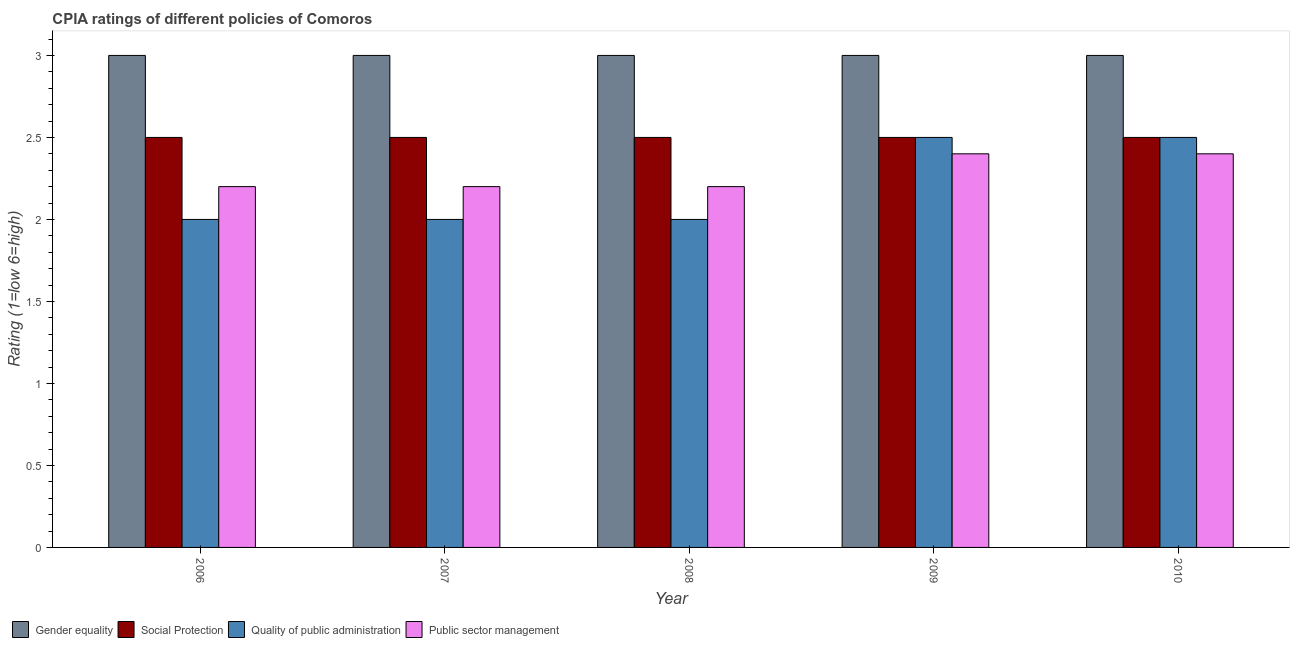How many groups of bars are there?
Offer a very short reply. 5. Are the number of bars on each tick of the X-axis equal?
Keep it short and to the point. Yes. What is the cpia rating of gender equality in 2008?
Your answer should be very brief. 3. Across all years, what is the minimum cpia rating of public sector management?
Make the answer very short. 2.2. What is the total cpia rating of social protection in the graph?
Offer a very short reply. 12.5. What is the difference between the cpia rating of public sector management in 2006 and that in 2010?
Your answer should be compact. -0.2. What is the difference between the cpia rating of gender equality in 2008 and the cpia rating of quality of public administration in 2010?
Make the answer very short. 0. What is the average cpia rating of public sector management per year?
Provide a short and direct response. 2.28. In how many years, is the cpia rating of quality of public administration greater than 2.6?
Provide a succinct answer. 0. What is the ratio of the cpia rating of social protection in 2007 to that in 2009?
Your response must be concise. 1. What is the difference between the highest and the second highest cpia rating of gender equality?
Your response must be concise. 0. In how many years, is the cpia rating of quality of public administration greater than the average cpia rating of quality of public administration taken over all years?
Your response must be concise. 2. Is the sum of the cpia rating of social protection in 2007 and 2009 greater than the maximum cpia rating of quality of public administration across all years?
Make the answer very short. Yes. What does the 2nd bar from the left in 2009 represents?
Give a very brief answer. Social Protection. What does the 3rd bar from the right in 2010 represents?
Provide a succinct answer. Social Protection. How many bars are there?
Offer a terse response. 20. Does the graph contain any zero values?
Your answer should be very brief. No. Where does the legend appear in the graph?
Your answer should be compact. Bottom left. How are the legend labels stacked?
Offer a terse response. Horizontal. What is the title of the graph?
Offer a terse response. CPIA ratings of different policies of Comoros. What is the Rating (1=low 6=high) in Public sector management in 2006?
Your response must be concise. 2.2. What is the Rating (1=low 6=high) of Gender equality in 2007?
Ensure brevity in your answer.  3. What is the Rating (1=low 6=high) in Public sector management in 2008?
Offer a terse response. 2.2. What is the Rating (1=low 6=high) of Quality of public administration in 2009?
Give a very brief answer. 2.5. What is the Rating (1=low 6=high) of Gender equality in 2010?
Provide a succinct answer. 3. What is the Rating (1=low 6=high) in Public sector management in 2010?
Your response must be concise. 2.4. Across all years, what is the maximum Rating (1=low 6=high) of Gender equality?
Your response must be concise. 3. Across all years, what is the maximum Rating (1=low 6=high) of Social Protection?
Provide a succinct answer. 2.5. Across all years, what is the maximum Rating (1=low 6=high) of Public sector management?
Offer a very short reply. 2.4. Across all years, what is the minimum Rating (1=low 6=high) in Gender equality?
Provide a succinct answer. 3. Across all years, what is the minimum Rating (1=low 6=high) of Social Protection?
Offer a very short reply. 2.5. Across all years, what is the minimum Rating (1=low 6=high) of Public sector management?
Keep it short and to the point. 2.2. What is the total Rating (1=low 6=high) in Quality of public administration in the graph?
Your answer should be compact. 11. What is the difference between the Rating (1=low 6=high) of Social Protection in 2006 and that in 2007?
Ensure brevity in your answer.  0. What is the difference between the Rating (1=low 6=high) in Quality of public administration in 2006 and that in 2007?
Your response must be concise. 0. What is the difference between the Rating (1=low 6=high) in Public sector management in 2006 and that in 2007?
Ensure brevity in your answer.  0. What is the difference between the Rating (1=low 6=high) of Social Protection in 2006 and that in 2008?
Your answer should be very brief. 0. What is the difference between the Rating (1=low 6=high) of Public sector management in 2006 and that in 2008?
Provide a short and direct response. 0. What is the difference between the Rating (1=low 6=high) in Gender equality in 2006 and that in 2009?
Offer a very short reply. 0. What is the difference between the Rating (1=low 6=high) of Social Protection in 2006 and that in 2009?
Offer a very short reply. 0. What is the difference between the Rating (1=low 6=high) in Quality of public administration in 2006 and that in 2009?
Give a very brief answer. -0.5. What is the difference between the Rating (1=low 6=high) in Public sector management in 2006 and that in 2009?
Ensure brevity in your answer.  -0.2. What is the difference between the Rating (1=low 6=high) in Gender equality in 2006 and that in 2010?
Your answer should be compact. 0. What is the difference between the Rating (1=low 6=high) of Social Protection in 2006 and that in 2010?
Give a very brief answer. 0. What is the difference between the Rating (1=low 6=high) in Quality of public administration in 2006 and that in 2010?
Make the answer very short. -0.5. What is the difference between the Rating (1=low 6=high) of Public sector management in 2006 and that in 2010?
Your response must be concise. -0.2. What is the difference between the Rating (1=low 6=high) in Gender equality in 2007 and that in 2008?
Your answer should be compact. 0. What is the difference between the Rating (1=low 6=high) in Social Protection in 2007 and that in 2008?
Your response must be concise. 0. What is the difference between the Rating (1=low 6=high) of Quality of public administration in 2007 and that in 2008?
Offer a very short reply. 0. What is the difference between the Rating (1=low 6=high) in Public sector management in 2007 and that in 2008?
Ensure brevity in your answer.  0. What is the difference between the Rating (1=low 6=high) in Public sector management in 2007 and that in 2009?
Ensure brevity in your answer.  -0.2. What is the difference between the Rating (1=low 6=high) in Public sector management in 2007 and that in 2010?
Your response must be concise. -0.2. What is the difference between the Rating (1=low 6=high) of Gender equality in 2008 and that in 2009?
Provide a succinct answer. 0. What is the difference between the Rating (1=low 6=high) of Social Protection in 2008 and that in 2009?
Make the answer very short. 0. What is the difference between the Rating (1=low 6=high) in Quality of public administration in 2008 and that in 2009?
Your answer should be compact. -0.5. What is the difference between the Rating (1=low 6=high) of Social Protection in 2008 and that in 2010?
Provide a short and direct response. 0. What is the difference between the Rating (1=low 6=high) in Gender equality in 2009 and that in 2010?
Your answer should be very brief. 0. What is the difference between the Rating (1=low 6=high) of Gender equality in 2006 and the Rating (1=low 6=high) of Social Protection in 2007?
Offer a very short reply. 0.5. What is the difference between the Rating (1=low 6=high) in Gender equality in 2006 and the Rating (1=low 6=high) in Quality of public administration in 2007?
Provide a short and direct response. 1. What is the difference between the Rating (1=low 6=high) in Gender equality in 2006 and the Rating (1=low 6=high) in Public sector management in 2007?
Offer a terse response. 0.8. What is the difference between the Rating (1=low 6=high) in Social Protection in 2006 and the Rating (1=low 6=high) in Public sector management in 2007?
Provide a succinct answer. 0.3. What is the difference between the Rating (1=low 6=high) of Social Protection in 2006 and the Rating (1=low 6=high) of Quality of public administration in 2008?
Offer a very short reply. 0.5. What is the difference between the Rating (1=low 6=high) of Quality of public administration in 2006 and the Rating (1=low 6=high) of Public sector management in 2008?
Your answer should be compact. -0.2. What is the difference between the Rating (1=low 6=high) of Gender equality in 2006 and the Rating (1=low 6=high) of Social Protection in 2009?
Make the answer very short. 0.5. What is the difference between the Rating (1=low 6=high) of Gender equality in 2006 and the Rating (1=low 6=high) of Public sector management in 2009?
Offer a very short reply. 0.6. What is the difference between the Rating (1=low 6=high) of Social Protection in 2006 and the Rating (1=low 6=high) of Quality of public administration in 2009?
Keep it short and to the point. 0. What is the difference between the Rating (1=low 6=high) in Social Protection in 2006 and the Rating (1=low 6=high) in Public sector management in 2009?
Provide a succinct answer. 0.1. What is the difference between the Rating (1=low 6=high) in Gender equality in 2006 and the Rating (1=low 6=high) in Quality of public administration in 2010?
Your answer should be compact. 0.5. What is the difference between the Rating (1=low 6=high) in Quality of public administration in 2006 and the Rating (1=low 6=high) in Public sector management in 2010?
Your response must be concise. -0.4. What is the difference between the Rating (1=low 6=high) in Gender equality in 2007 and the Rating (1=low 6=high) in Social Protection in 2008?
Offer a terse response. 0.5. What is the difference between the Rating (1=low 6=high) of Gender equality in 2007 and the Rating (1=low 6=high) of Quality of public administration in 2008?
Offer a terse response. 1. What is the difference between the Rating (1=low 6=high) of Gender equality in 2007 and the Rating (1=low 6=high) of Public sector management in 2008?
Ensure brevity in your answer.  0.8. What is the difference between the Rating (1=low 6=high) of Social Protection in 2007 and the Rating (1=low 6=high) of Quality of public administration in 2008?
Your answer should be very brief. 0.5. What is the difference between the Rating (1=low 6=high) in Quality of public administration in 2007 and the Rating (1=low 6=high) in Public sector management in 2008?
Offer a very short reply. -0.2. What is the difference between the Rating (1=low 6=high) of Gender equality in 2007 and the Rating (1=low 6=high) of Quality of public administration in 2009?
Keep it short and to the point. 0.5. What is the difference between the Rating (1=low 6=high) in Gender equality in 2007 and the Rating (1=low 6=high) in Public sector management in 2009?
Keep it short and to the point. 0.6. What is the difference between the Rating (1=low 6=high) in Social Protection in 2007 and the Rating (1=low 6=high) in Quality of public administration in 2009?
Provide a short and direct response. 0. What is the difference between the Rating (1=low 6=high) of Quality of public administration in 2007 and the Rating (1=low 6=high) of Public sector management in 2009?
Your answer should be compact. -0.4. What is the difference between the Rating (1=low 6=high) in Gender equality in 2007 and the Rating (1=low 6=high) in Social Protection in 2010?
Provide a short and direct response. 0.5. What is the difference between the Rating (1=low 6=high) of Social Protection in 2007 and the Rating (1=low 6=high) of Quality of public administration in 2010?
Keep it short and to the point. 0. What is the difference between the Rating (1=low 6=high) in Social Protection in 2008 and the Rating (1=low 6=high) in Public sector management in 2009?
Your response must be concise. 0.1. What is the difference between the Rating (1=low 6=high) of Gender equality in 2008 and the Rating (1=low 6=high) of Social Protection in 2010?
Ensure brevity in your answer.  0.5. What is the difference between the Rating (1=low 6=high) of Gender equality in 2008 and the Rating (1=low 6=high) of Quality of public administration in 2010?
Give a very brief answer. 0.5. What is the difference between the Rating (1=low 6=high) in Quality of public administration in 2008 and the Rating (1=low 6=high) in Public sector management in 2010?
Ensure brevity in your answer.  -0.4. What is the difference between the Rating (1=low 6=high) in Gender equality in 2009 and the Rating (1=low 6=high) in Public sector management in 2010?
Keep it short and to the point. 0.6. What is the average Rating (1=low 6=high) of Social Protection per year?
Your answer should be very brief. 2.5. What is the average Rating (1=low 6=high) in Public sector management per year?
Provide a short and direct response. 2.28. In the year 2006, what is the difference between the Rating (1=low 6=high) of Gender equality and Rating (1=low 6=high) of Quality of public administration?
Offer a very short reply. 1. In the year 2006, what is the difference between the Rating (1=low 6=high) in Social Protection and Rating (1=low 6=high) in Public sector management?
Make the answer very short. 0.3. In the year 2006, what is the difference between the Rating (1=low 6=high) of Quality of public administration and Rating (1=low 6=high) of Public sector management?
Provide a short and direct response. -0.2. In the year 2007, what is the difference between the Rating (1=low 6=high) of Gender equality and Rating (1=low 6=high) of Social Protection?
Offer a very short reply. 0.5. In the year 2007, what is the difference between the Rating (1=low 6=high) of Gender equality and Rating (1=low 6=high) of Public sector management?
Your answer should be compact. 0.8. In the year 2007, what is the difference between the Rating (1=low 6=high) of Social Protection and Rating (1=low 6=high) of Public sector management?
Offer a very short reply. 0.3. In the year 2007, what is the difference between the Rating (1=low 6=high) of Quality of public administration and Rating (1=low 6=high) of Public sector management?
Ensure brevity in your answer.  -0.2. In the year 2008, what is the difference between the Rating (1=low 6=high) in Gender equality and Rating (1=low 6=high) in Quality of public administration?
Give a very brief answer. 1. In the year 2008, what is the difference between the Rating (1=low 6=high) in Social Protection and Rating (1=low 6=high) in Quality of public administration?
Provide a short and direct response. 0.5. In the year 2008, what is the difference between the Rating (1=low 6=high) of Social Protection and Rating (1=low 6=high) of Public sector management?
Ensure brevity in your answer.  0.3. In the year 2008, what is the difference between the Rating (1=low 6=high) of Quality of public administration and Rating (1=low 6=high) of Public sector management?
Your response must be concise. -0.2. In the year 2009, what is the difference between the Rating (1=low 6=high) in Gender equality and Rating (1=low 6=high) in Social Protection?
Provide a succinct answer. 0.5. In the year 2009, what is the difference between the Rating (1=low 6=high) in Gender equality and Rating (1=low 6=high) in Quality of public administration?
Your answer should be very brief. 0.5. In the year 2009, what is the difference between the Rating (1=low 6=high) in Social Protection and Rating (1=low 6=high) in Quality of public administration?
Provide a short and direct response. 0. In the year 2009, what is the difference between the Rating (1=low 6=high) of Quality of public administration and Rating (1=low 6=high) of Public sector management?
Keep it short and to the point. 0.1. In the year 2010, what is the difference between the Rating (1=low 6=high) of Gender equality and Rating (1=low 6=high) of Social Protection?
Your answer should be very brief. 0.5. In the year 2010, what is the difference between the Rating (1=low 6=high) in Gender equality and Rating (1=low 6=high) in Quality of public administration?
Offer a terse response. 0.5. In the year 2010, what is the difference between the Rating (1=low 6=high) of Social Protection and Rating (1=low 6=high) of Quality of public administration?
Offer a terse response. 0. In the year 2010, what is the difference between the Rating (1=low 6=high) in Social Protection and Rating (1=low 6=high) in Public sector management?
Provide a succinct answer. 0.1. In the year 2010, what is the difference between the Rating (1=low 6=high) in Quality of public administration and Rating (1=low 6=high) in Public sector management?
Keep it short and to the point. 0.1. What is the ratio of the Rating (1=low 6=high) in Gender equality in 2006 to that in 2007?
Provide a succinct answer. 1. What is the ratio of the Rating (1=low 6=high) in Social Protection in 2006 to that in 2007?
Your answer should be very brief. 1. What is the ratio of the Rating (1=low 6=high) in Gender equality in 2006 to that in 2008?
Your answer should be compact. 1. What is the ratio of the Rating (1=low 6=high) in Social Protection in 2006 to that in 2008?
Make the answer very short. 1. What is the ratio of the Rating (1=low 6=high) in Gender equality in 2006 to that in 2009?
Your answer should be compact. 1. What is the ratio of the Rating (1=low 6=high) in Social Protection in 2006 to that in 2009?
Ensure brevity in your answer.  1. What is the ratio of the Rating (1=low 6=high) in Quality of public administration in 2006 to that in 2009?
Ensure brevity in your answer.  0.8. What is the ratio of the Rating (1=low 6=high) of Gender equality in 2006 to that in 2010?
Your answer should be very brief. 1. What is the ratio of the Rating (1=low 6=high) in Social Protection in 2006 to that in 2010?
Ensure brevity in your answer.  1. What is the ratio of the Rating (1=low 6=high) of Quality of public administration in 2006 to that in 2010?
Provide a succinct answer. 0.8. What is the ratio of the Rating (1=low 6=high) in Gender equality in 2007 to that in 2008?
Give a very brief answer. 1. What is the ratio of the Rating (1=low 6=high) in Quality of public administration in 2007 to that in 2008?
Keep it short and to the point. 1. What is the ratio of the Rating (1=low 6=high) of Public sector management in 2007 to that in 2008?
Your answer should be very brief. 1. What is the ratio of the Rating (1=low 6=high) of Gender equality in 2007 to that in 2009?
Offer a terse response. 1. What is the ratio of the Rating (1=low 6=high) of Social Protection in 2007 to that in 2009?
Your answer should be very brief. 1. What is the ratio of the Rating (1=low 6=high) of Quality of public administration in 2007 to that in 2009?
Your response must be concise. 0.8. What is the ratio of the Rating (1=low 6=high) in Quality of public administration in 2008 to that in 2009?
Ensure brevity in your answer.  0.8. What is the ratio of the Rating (1=low 6=high) of Public sector management in 2008 to that in 2009?
Ensure brevity in your answer.  0.92. What is the ratio of the Rating (1=low 6=high) in Gender equality in 2008 to that in 2010?
Your answer should be compact. 1. What is the ratio of the Rating (1=low 6=high) of Social Protection in 2008 to that in 2010?
Your answer should be compact. 1. What is the ratio of the Rating (1=low 6=high) of Quality of public administration in 2008 to that in 2010?
Your answer should be very brief. 0.8. What is the ratio of the Rating (1=low 6=high) in Gender equality in 2009 to that in 2010?
Your response must be concise. 1. What is the ratio of the Rating (1=low 6=high) of Quality of public administration in 2009 to that in 2010?
Your answer should be very brief. 1. What is the difference between the highest and the second highest Rating (1=low 6=high) of Public sector management?
Make the answer very short. 0. What is the difference between the highest and the lowest Rating (1=low 6=high) of Gender equality?
Ensure brevity in your answer.  0. What is the difference between the highest and the lowest Rating (1=low 6=high) of Public sector management?
Ensure brevity in your answer.  0.2. 